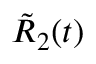Convert formula to latex. <formula><loc_0><loc_0><loc_500><loc_500>{ \tilde { R } } _ { 2 } ( t )</formula> 